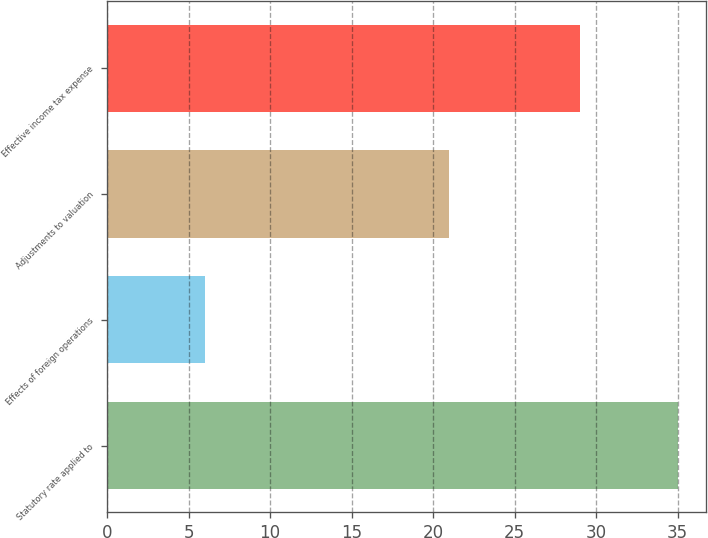<chart> <loc_0><loc_0><loc_500><loc_500><bar_chart><fcel>Statutory rate applied to<fcel>Effects of foreign operations<fcel>Adjustments to valuation<fcel>Effective income tax expense<nl><fcel>35<fcel>6<fcel>21<fcel>29<nl></chart> 